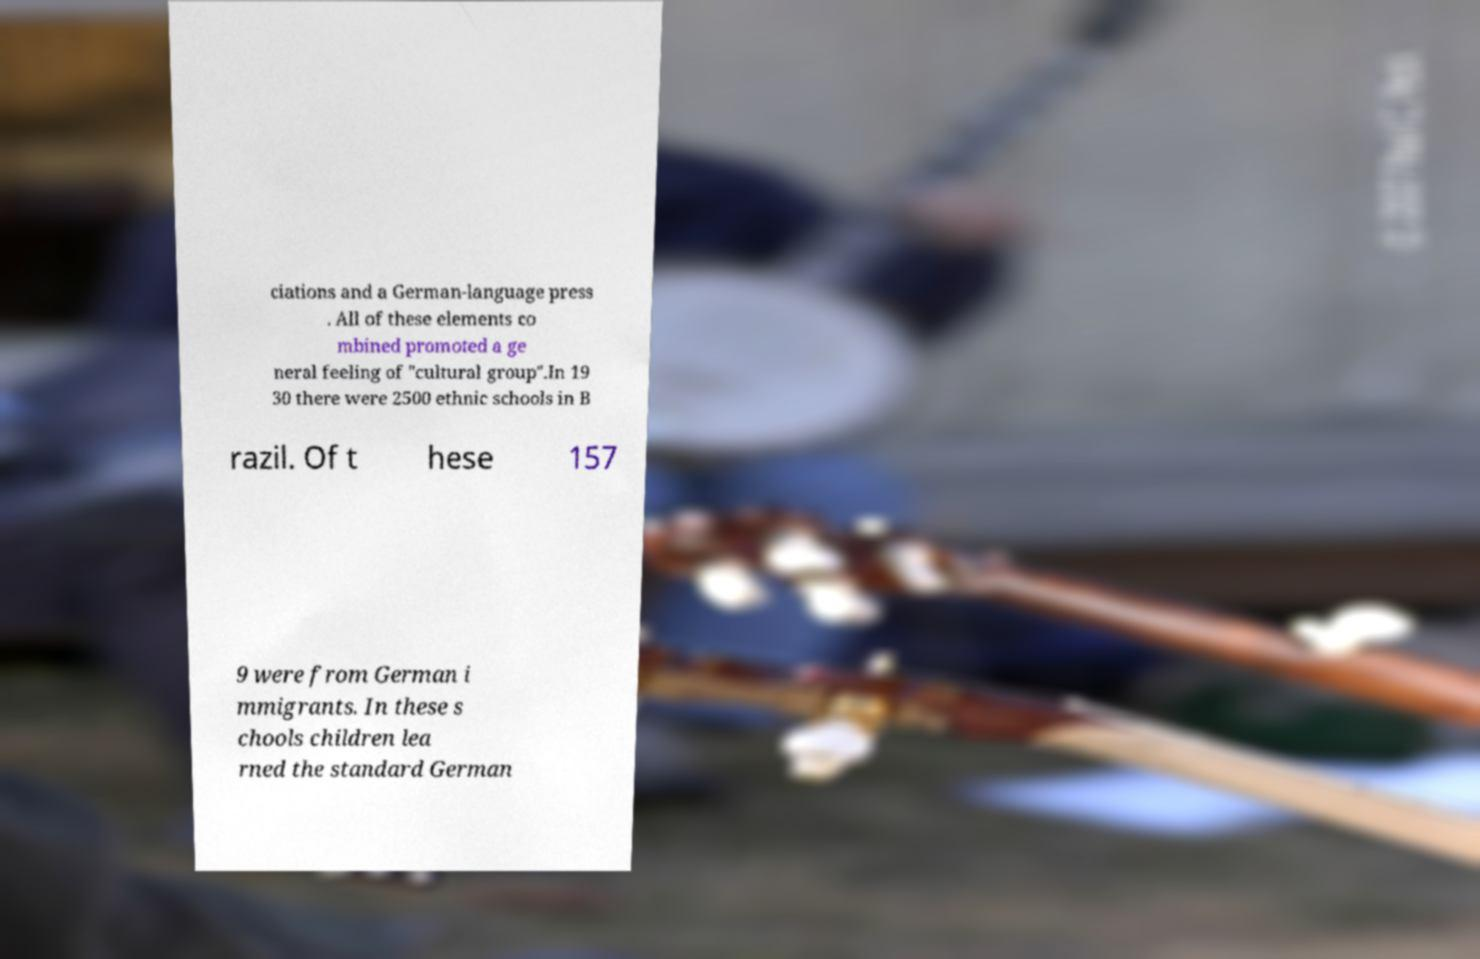Could you assist in decoding the text presented in this image and type it out clearly? ciations and a German-language press . All of these elements co mbined promoted a ge neral feeling of "cultural group".In 19 30 there were 2500 ethnic schools in B razil. Of t hese 157 9 were from German i mmigrants. In these s chools children lea rned the standard German 